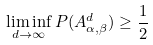Convert formula to latex. <formula><loc_0><loc_0><loc_500><loc_500>\liminf _ { d \rightarrow \infty } P ( A ^ { d } _ { \alpha , \beta } ) \geq \frac { 1 } { 2 }</formula> 